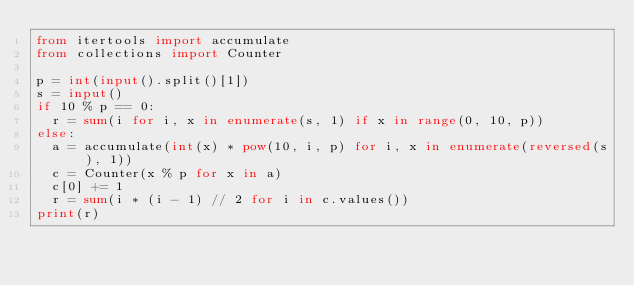<code> <loc_0><loc_0><loc_500><loc_500><_Python_>from itertools import accumulate
from collections import Counter

p = int(input().split()[1])
s = input()
if 10 % p == 0:
  r = sum(i for i, x in enumerate(s, 1) if x in range(0, 10, p))
else:
  a = accumulate(int(x) * pow(10, i, p) for i, x in enumerate(reversed(s), 1))
  c = Counter(x % p for x in a) 
  c[0] += 1
  r = sum(i * (i - 1) // 2 for i in c.values())
print(r)
</code> 